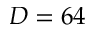Convert formula to latex. <formula><loc_0><loc_0><loc_500><loc_500>D = 6 4</formula> 